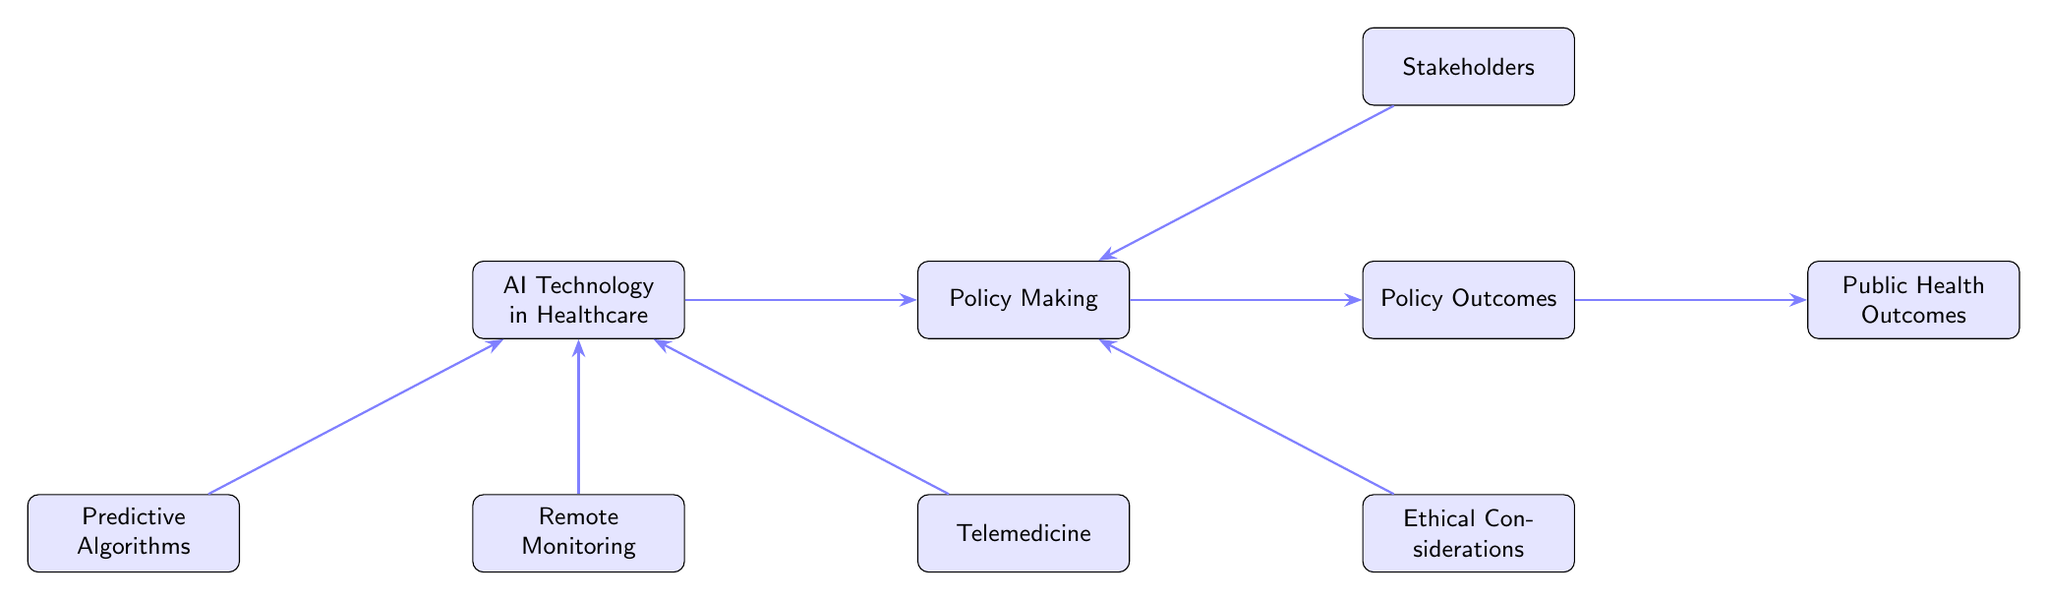What are the three components that AI technology in healthcare supports? The diagram shows that AI technology in healthcare is supported by three components: predictive algorithms, remote monitoring, and telemedicine. These are indicated as entities directly related to AI technology in the diagram.
Answer: predictive algorithms, remote monitoring, telemedicine How many main entities are present in the diagram? By counting the entities shown in the diagram, we find a total of eight main nodes, including AI technology in healthcare, predictive algorithms, remote monitoring, telemedicine, policy making, stakeholders, ethical considerations, and public health outcomes.
Answer: 8 What role do stakeholders have in the policy making process? The diagram indicates that stakeholders engage with the policy-making process, suggesting that they play an active role in influencing healthcare policies based on their interests and agendas.
Answer: engage What is the relationship between policy making and public health outcomes? The diagram illustrates that policy making shapes public health outcomes. This means that decisions made in the policy-making stage have a direct impact on the results seen in public health.
Answer: shapes Which entity informs policy making according to the diagram? The diagram specifically states that AI technology in healthcare informs the policy-making process, indicating that insights gained from AI applications influence how policies are created and updated.
Answer: AI Technology in Healthcare What guides policy making in relation to ethical considerations? The relationship shown in the diagram indicates that ethical considerations guide policy making, suggesting that ethical frameworks help steer the direction and nature of health policies developed.
Answer: guide How do public health outcomes influence health? According to the diagram, public health outcomes influence health, indicating that the results derived from health policies directly affect population health metrics, behaviors, and overall well-being.
Answer: influence What enhances remote monitoring technologies in healthcare? The diagram shows that remote monitoring is enhanced by AI technology in healthcare, implying that advancements in AI improve the effectiveness and precision of remote monitoring systems used in patient care.
Answer: enhanced by AI Technology in Healthcare 